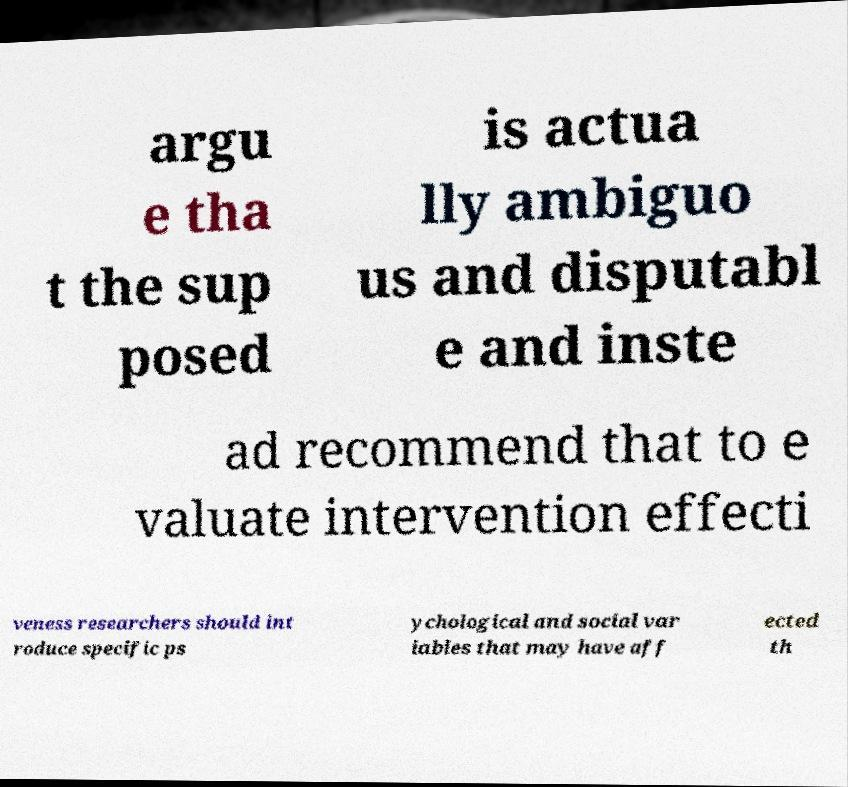There's text embedded in this image that I need extracted. Can you transcribe it verbatim? argu e tha t the sup posed is actua lly ambiguo us and disputabl e and inste ad recommend that to e valuate intervention effecti veness researchers should int roduce specific ps ychological and social var iables that may have aff ected th 